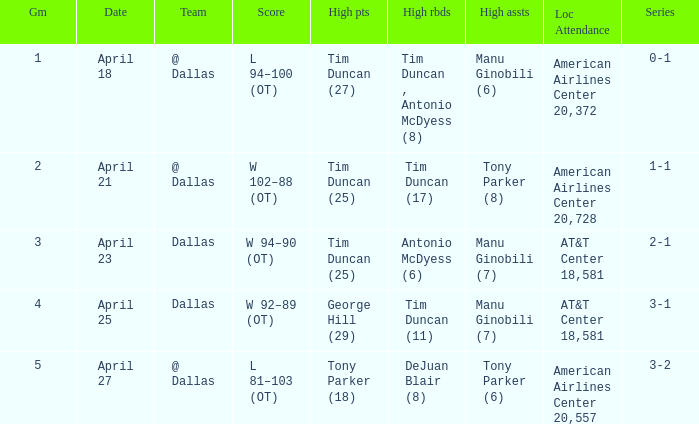When 0-1 is the series who has the highest amount of assists? Manu Ginobili (6). Give me the full table as a dictionary. {'header': ['Gm', 'Date', 'Team', 'Score', 'High pts', 'High rbds', 'High assts', 'Loc Attendance', 'Series'], 'rows': [['1', 'April 18', '@ Dallas', 'L 94–100 (OT)', 'Tim Duncan (27)', 'Tim Duncan , Antonio McDyess (8)', 'Manu Ginobili (6)', 'American Airlines Center 20,372', '0-1'], ['2', 'April 21', '@ Dallas', 'W 102–88 (OT)', 'Tim Duncan (25)', 'Tim Duncan (17)', 'Tony Parker (8)', 'American Airlines Center 20,728', '1-1'], ['3', 'April 23', 'Dallas', 'W 94–90 (OT)', 'Tim Duncan (25)', 'Antonio McDyess (6)', 'Manu Ginobili (7)', 'AT&T Center 18,581', '2-1'], ['4', 'April 25', 'Dallas', 'W 92–89 (OT)', 'George Hill (29)', 'Tim Duncan (11)', 'Manu Ginobili (7)', 'AT&T Center 18,581', '3-1'], ['5', 'April 27', '@ Dallas', 'L 81–103 (OT)', 'Tony Parker (18)', 'DeJuan Blair (8)', 'Tony Parker (6)', 'American Airlines Center 20,557', '3-2']]} 